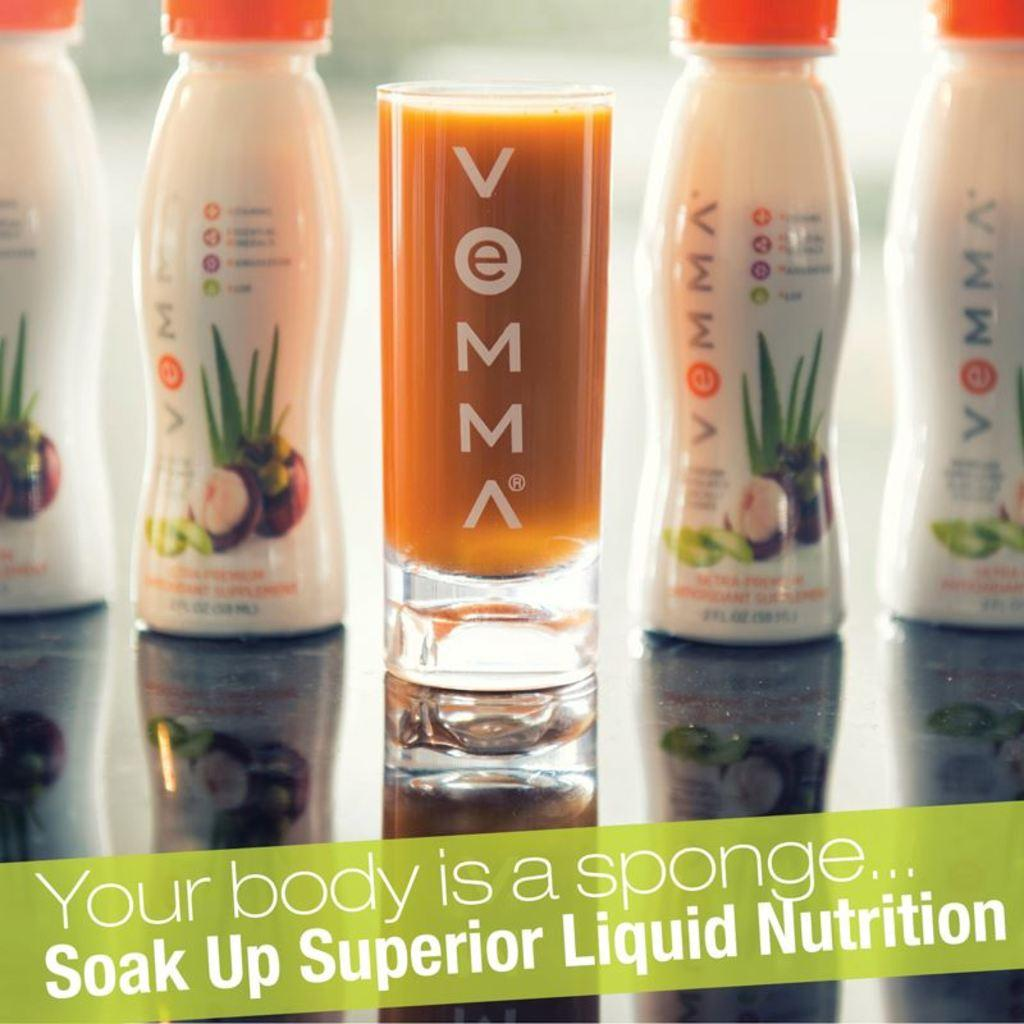<image>
Give a short and clear explanation of the subsequent image. Advertisement for Vemma drink with a green label saying "Your body is a Sponge" near the bottom. 